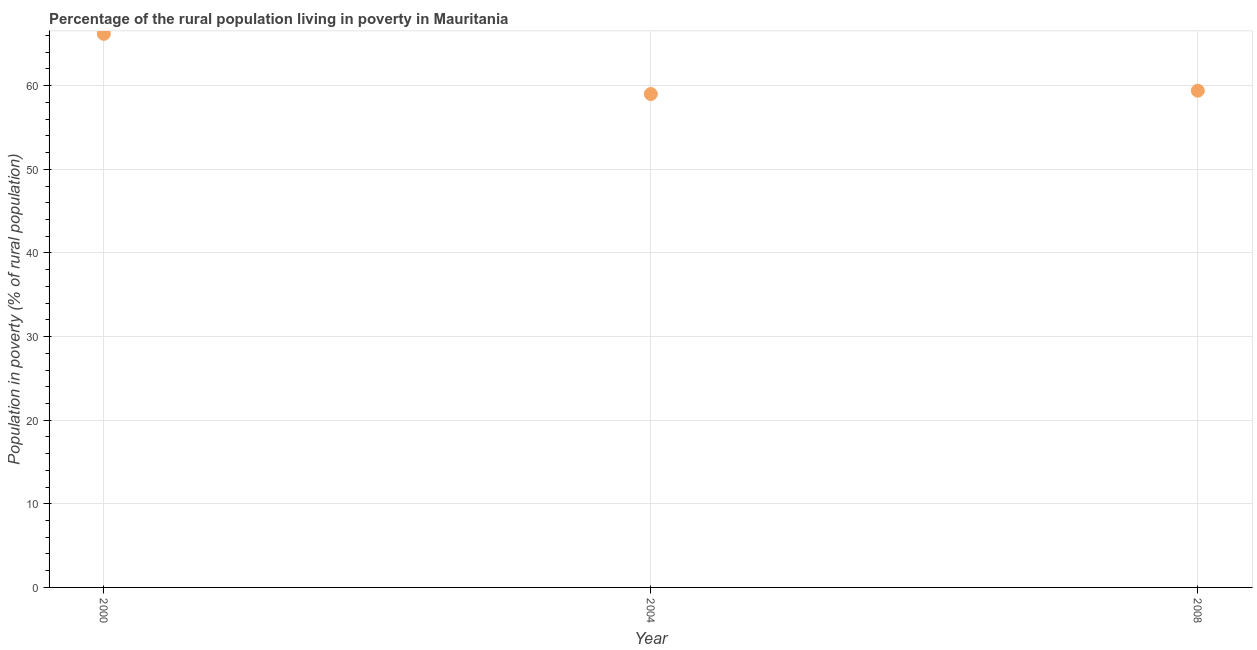What is the percentage of rural population living below poverty line in 2008?
Ensure brevity in your answer.  59.4. Across all years, what is the maximum percentage of rural population living below poverty line?
Offer a terse response. 66.2. In which year was the percentage of rural population living below poverty line minimum?
Provide a succinct answer. 2004. What is the sum of the percentage of rural population living below poverty line?
Give a very brief answer. 184.6. What is the difference between the percentage of rural population living below poverty line in 2004 and 2008?
Your answer should be very brief. -0.4. What is the average percentage of rural population living below poverty line per year?
Keep it short and to the point. 61.53. What is the median percentage of rural population living below poverty line?
Offer a terse response. 59.4. In how many years, is the percentage of rural population living below poverty line greater than 32 %?
Keep it short and to the point. 3. Do a majority of the years between 2000 and 2004 (inclusive) have percentage of rural population living below poverty line greater than 46 %?
Give a very brief answer. Yes. What is the ratio of the percentage of rural population living below poverty line in 2004 to that in 2008?
Your answer should be compact. 0.99. Is the percentage of rural population living below poverty line in 2004 less than that in 2008?
Give a very brief answer. Yes. What is the difference between the highest and the second highest percentage of rural population living below poverty line?
Ensure brevity in your answer.  6.8. Is the sum of the percentage of rural population living below poverty line in 2004 and 2008 greater than the maximum percentage of rural population living below poverty line across all years?
Your response must be concise. Yes. What is the difference between the highest and the lowest percentage of rural population living below poverty line?
Make the answer very short. 7.2. Does the percentage of rural population living below poverty line monotonically increase over the years?
Keep it short and to the point. No. How many dotlines are there?
Give a very brief answer. 1. How many years are there in the graph?
Provide a succinct answer. 3. What is the difference between two consecutive major ticks on the Y-axis?
Offer a terse response. 10. Does the graph contain grids?
Your answer should be compact. Yes. What is the title of the graph?
Your answer should be very brief. Percentage of the rural population living in poverty in Mauritania. What is the label or title of the X-axis?
Your response must be concise. Year. What is the label or title of the Y-axis?
Your answer should be very brief. Population in poverty (% of rural population). What is the Population in poverty (% of rural population) in 2000?
Make the answer very short. 66.2. What is the Population in poverty (% of rural population) in 2004?
Your answer should be compact. 59. What is the Population in poverty (% of rural population) in 2008?
Give a very brief answer. 59.4. What is the difference between the Population in poverty (% of rural population) in 2000 and 2008?
Ensure brevity in your answer.  6.8. What is the difference between the Population in poverty (% of rural population) in 2004 and 2008?
Offer a terse response. -0.4. What is the ratio of the Population in poverty (% of rural population) in 2000 to that in 2004?
Ensure brevity in your answer.  1.12. What is the ratio of the Population in poverty (% of rural population) in 2000 to that in 2008?
Offer a very short reply. 1.11. What is the ratio of the Population in poverty (% of rural population) in 2004 to that in 2008?
Offer a very short reply. 0.99. 